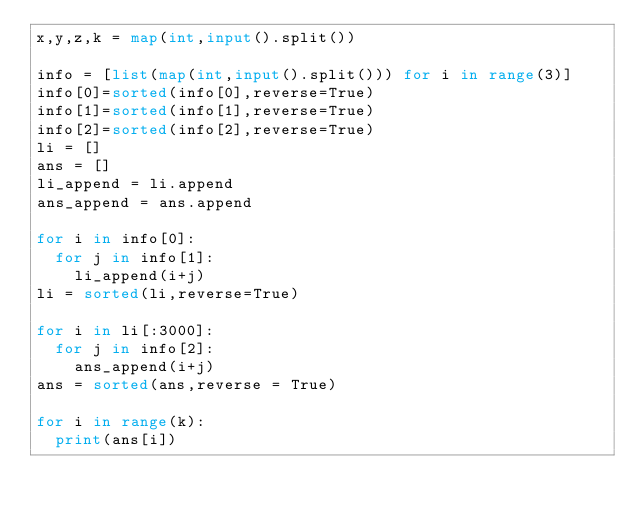<code> <loc_0><loc_0><loc_500><loc_500><_Python_>x,y,z,k = map(int,input().split())

info = [list(map(int,input().split())) for i in range(3)]
info[0]=sorted(info[0],reverse=True)
info[1]=sorted(info[1],reverse=True)
info[2]=sorted(info[2],reverse=True)
li = []
ans = []
li_append = li.append 
ans_append = ans.append

for i in info[0]:
  for j in info[1]:
    li_append(i+j)
li = sorted(li,reverse=True)

for i in li[:3000]:
  for j in info[2]:
    ans_append(i+j)
ans = sorted(ans,reverse = True)

for i in range(k):
  print(ans[i])</code> 